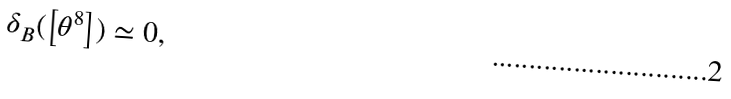<formula> <loc_0><loc_0><loc_500><loc_500>\delta _ { B } ( \left [ \theta ^ { 8 } \right ] ) \simeq 0 ,</formula> 